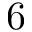Convert formula to latex. <formula><loc_0><loc_0><loc_500><loc_500>6</formula> 